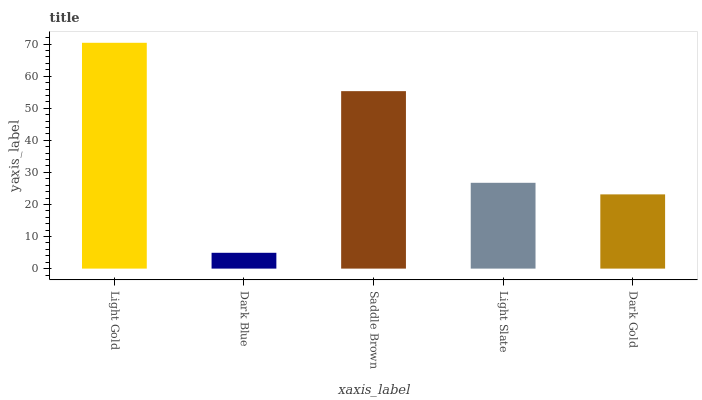Is Saddle Brown the minimum?
Answer yes or no. No. Is Saddle Brown the maximum?
Answer yes or no. No. Is Saddle Brown greater than Dark Blue?
Answer yes or no. Yes. Is Dark Blue less than Saddle Brown?
Answer yes or no. Yes. Is Dark Blue greater than Saddle Brown?
Answer yes or no. No. Is Saddle Brown less than Dark Blue?
Answer yes or no. No. Is Light Slate the high median?
Answer yes or no. Yes. Is Light Slate the low median?
Answer yes or no. Yes. Is Saddle Brown the high median?
Answer yes or no. No. Is Dark Gold the low median?
Answer yes or no. No. 